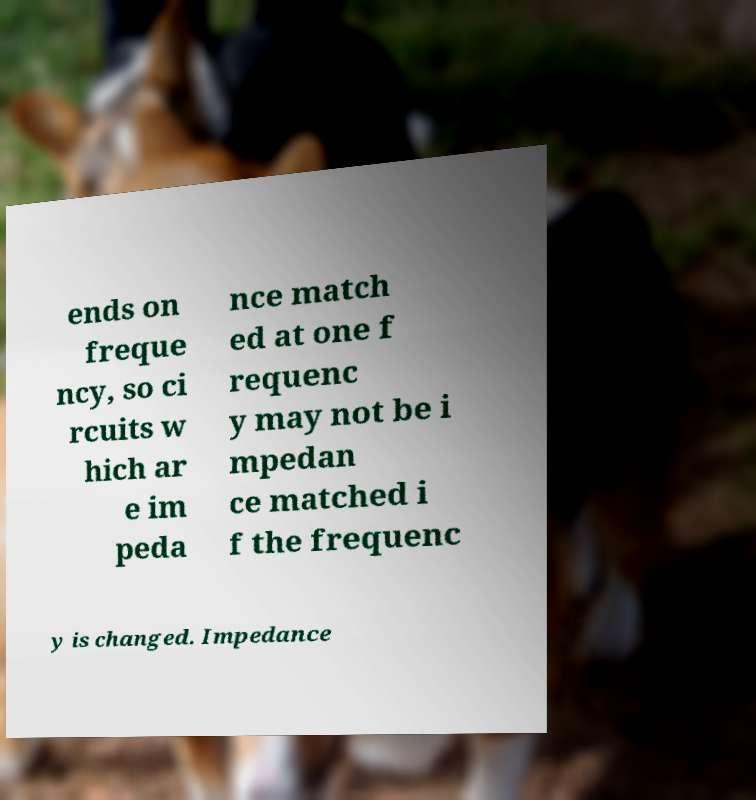For documentation purposes, I need the text within this image transcribed. Could you provide that? ends on freque ncy, so ci rcuits w hich ar e im peda nce match ed at one f requenc y may not be i mpedan ce matched i f the frequenc y is changed. Impedance 